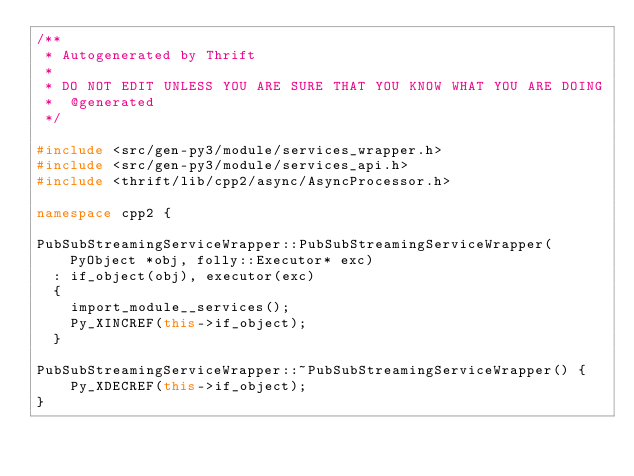<code> <loc_0><loc_0><loc_500><loc_500><_C++_>/**
 * Autogenerated by Thrift
 *
 * DO NOT EDIT UNLESS YOU ARE SURE THAT YOU KNOW WHAT YOU ARE DOING
 *  @generated
 */

#include <src/gen-py3/module/services_wrapper.h>
#include <src/gen-py3/module/services_api.h>
#include <thrift/lib/cpp2/async/AsyncProcessor.h>

namespace cpp2 {

PubSubStreamingServiceWrapper::PubSubStreamingServiceWrapper(PyObject *obj, folly::Executor* exc)
  : if_object(obj), executor(exc)
  {
    import_module__services();
    Py_XINCREF(this->if_object);
  }

PubSubStreamingServiceWrapper::~PubSubStreamingServiceWrapper() {
    Py_XDECREF(this->if_object);
}
</code> 